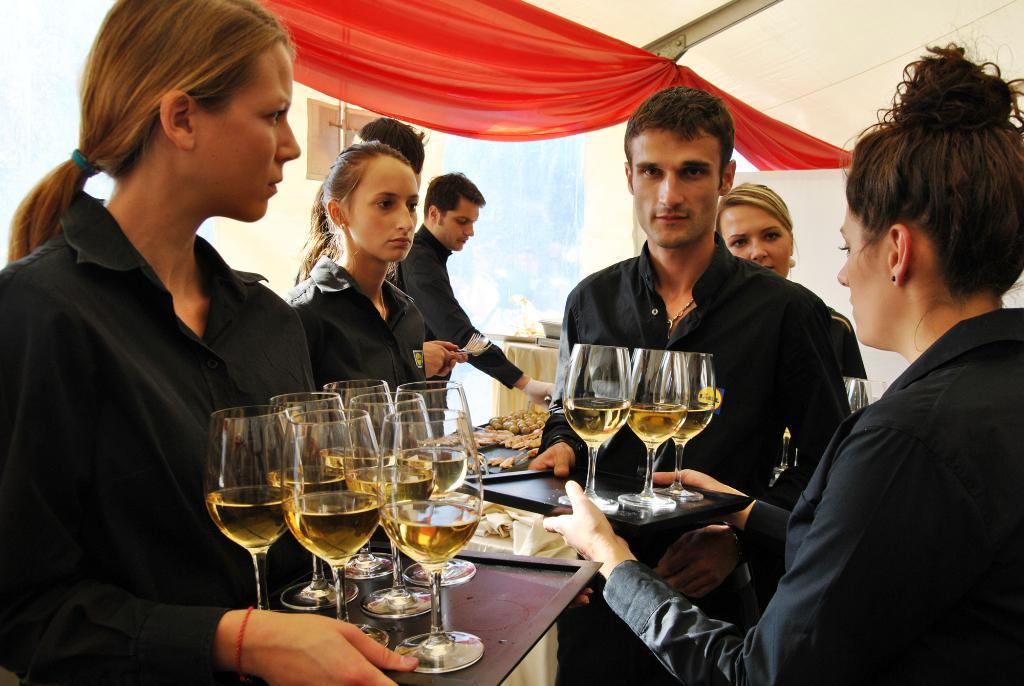What are the two ladies in the image doing? The two ladies are holding trays with glasses. What can be seen in the background of the image? There are many persons standing in the background, and there are food items present as well. What is the color of the cloth hanging from the ceiling? The cloth hanging from the ceiling is red. What type of education is being provided by the scarecrow in the image? There is no scarecrow present in the image, so no education is being provided. What type of meal is being served by the ladies in the image? The provided facts do not specify the type of meal being served; only that the ladies are holding trays with glasses. 